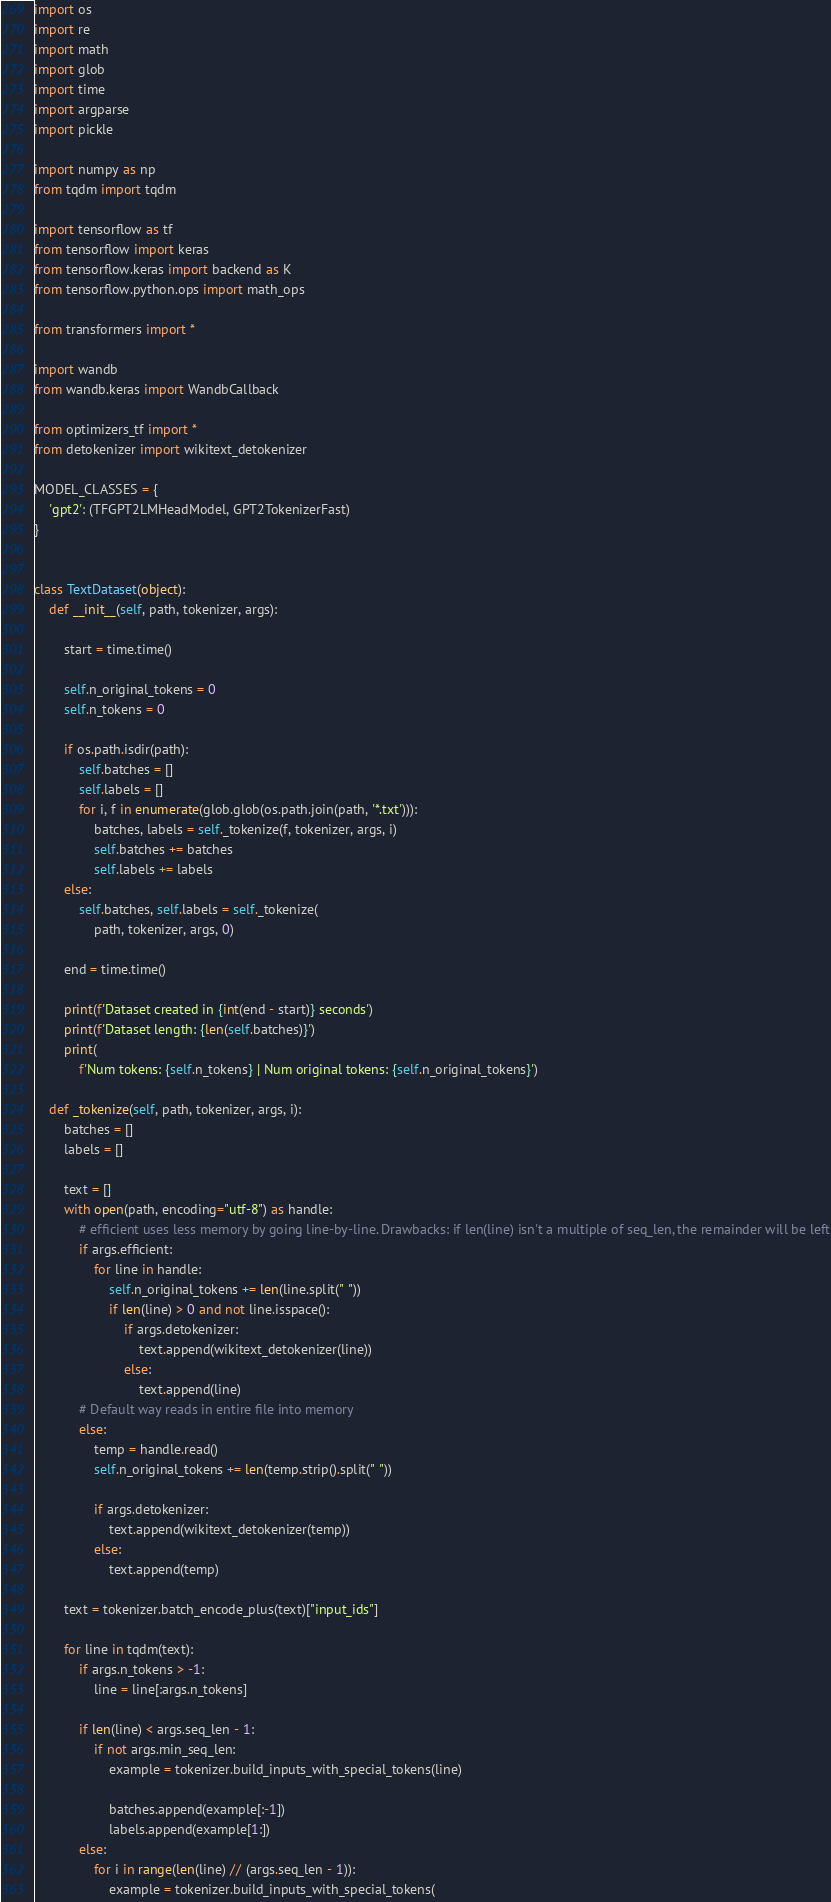<code> <loc_0><loc_0><loc_500><loc_500><_Python_>import os
import re
import math
import glob
import time
import argparse
import pickle

import numpy as np
from tqdm import tqdm

import tensorflow as tf
from tensorflow import keras
from tensorflow.keras import backend as K
from tensorflow.python.ops import math_ops

from transformers import *

import wandb
from wandb.keras import WandbCallback

from optimizers_tf import *
from detokenizer import wikitext_detokenizer

MODEL_CLASSES = {
    'gpt2': (TFGPT2LMHeadModel, GPT2TokenizerFast)
}


class TextDataset(object):
    def __init__(self, path, tokenizer, args):

        start = time.time()

        self.n_original_tokens = 0
        self.n_tokens = 0

        if os.path.isdir(path):
            self.batches = []
            self.labels = []
            for i, f in enumerate(glob.glob(os.path.join(path, '*.txt'))):
                batches, labels = self._tokenize(f, tokenizer, args, i)
                self.batches += batches
                self.labels += labels
        else:
            self.batches, self.labels = self._tokenize(
                path, tokenizer, args, 0)

        end = time.time()

        print(f'Dataset created in {int(end - start)} seconds')
        print(f'Dataset length: {len(self.batches)}')
        print(
            f'Num tokens: {self.n_tokens} | Num original tokens: {self.n_original_tokens}')

    def _tokenize(self, path, tokenizer, args, i):
        batches = []
        labels = []

        text = []
        with open(path, encoding="utf-8") as handle:
            # efficient uses less memory by going line-by-line. Drawbacks: if len(line) isn't a multiple of seq_len, the remainder will be left
            if args.efficient:
                for line in handle:
                    self.n_original_tokens += len(line.split(" "))
                    if len(line) > 0 and not line.isspace():
                        if args.detokenizer:
                            text.append(wikitext_detokenizer(line))
                        else:
                            text.append(line)
            # Default way reads in entire file into memory
            else:
                temp = handle.read()
                self.n_original_tokens += len(temp.strip().split(" "))

                if args.detokenizer:
                    text.append(wikitext_detokenizer(temp))
                else:
                    text.append(temp)

        text = tokenizer.batch_encode_plus(text)["input_ids"]

        for line in tqdm(text):
            if args.n_tokens > -1:
                line = line[:args.n_tokens]

            if len(line) < args.seq_len - 1:
                if not args.min_seq_len:
                    example = tokenizer.build_inputs_with_special_tokens(line)

                    batches.append(example[:-1])
                    labels.append(example[1:])
            else:
                for i in range(len(line) // (args.seq_len - 1)):
                    example = tokenizer.build_inputs_with_special_tokens(</code> 